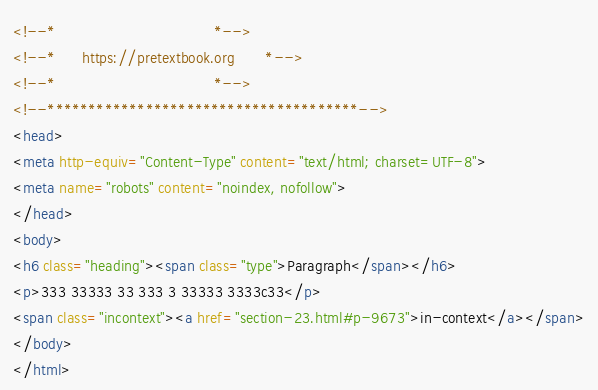<code> <loc_0><loc_0><loc_500><loc_500><_HTML_><!--*                                    *-->
<!--*      https://pretextbook.org       *-->
<!--*                                    *-->
<!--**************************************-->
<head>
<meta http-equiv="Content-Type" content="text/html; charset=UTF-8">
<meta name="robots" content="noindex, nofollow">
</head>
<body>
<h6 class="heading"><span class="type">Paragraph</span></h6>
<p>333 33333 33 333 3 33333 3333c33</p>
<span class="incontext"><a href="section-23.html#p-9673">in-context</a></span>
</body>
</html>
</code> 